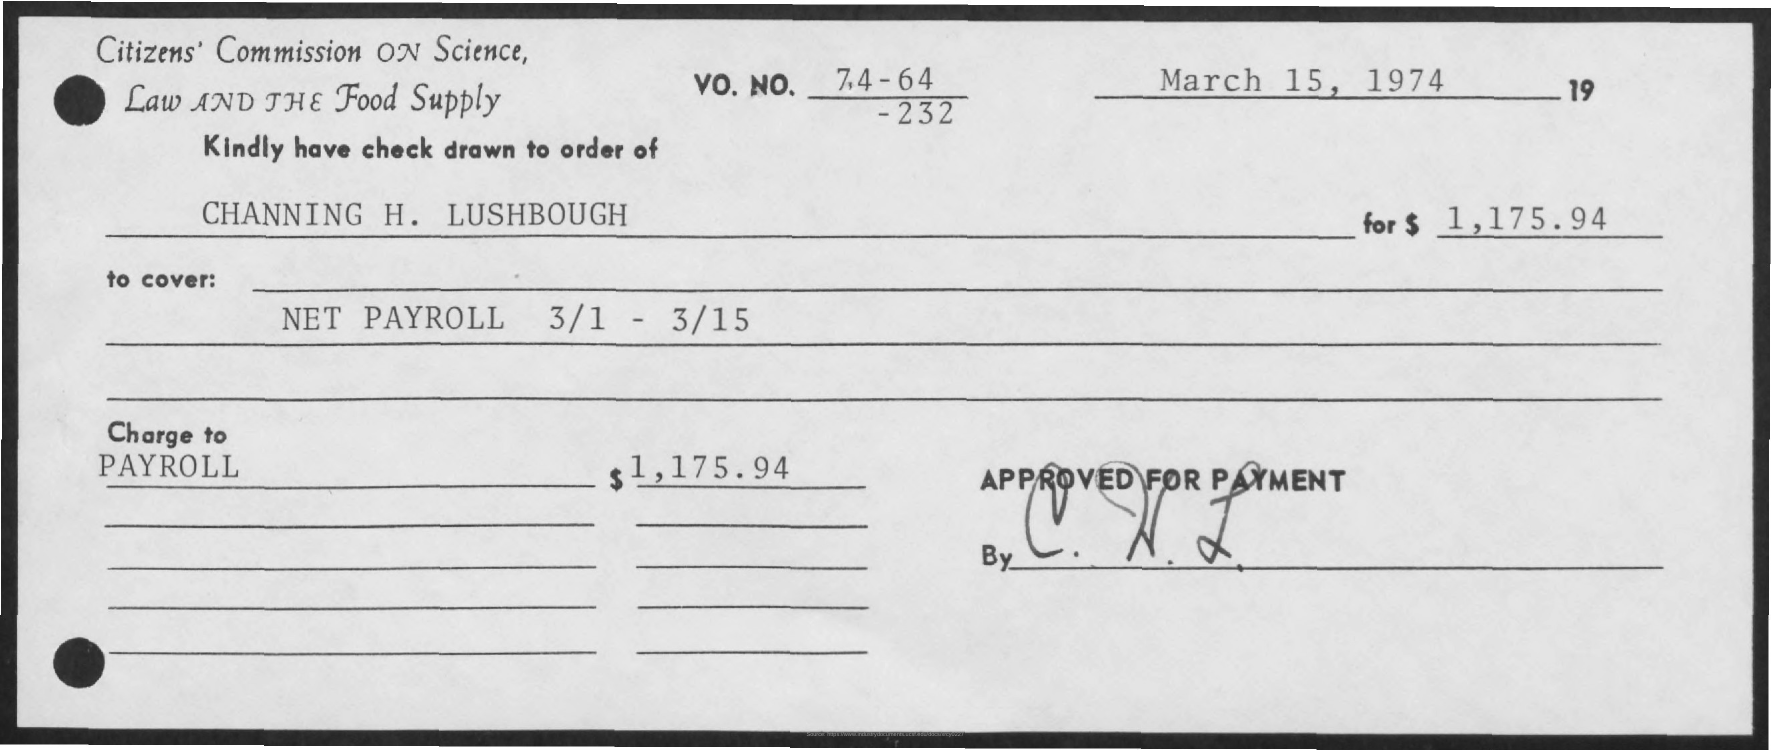Highlight a few significant elements in this photo. The amount to be paid is $1,175.94. The date mentioned is March 15, 1974. Please ensure that a check has been drawn in the order of Channing H. Lushbough. 